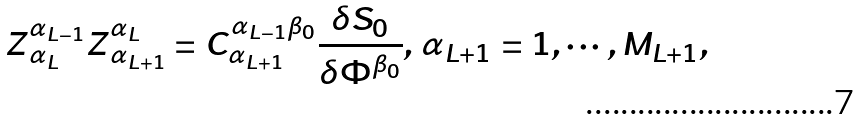Convert formula to latex. <formula><loc_0><loc_0><loc_500><loc_500>Z _ { \, \alpha _ { L } } ^ { \alpha _ { L - 1 } } Z _ { \, \alpha _ { L + 1 } } ^ { \alpha _ { L } } = C _ { \alpha _ { L + 1 } } ^ { \alpha _ { L - 1 } \beta _ { 0 } } \frac { \delta S _ { 0 } } { \delta \Phi ^ { \beta _ { 0 } } } , \, \alpha _ { L + 1 } = 1 , \cdots , M _ { L + 1 } ,</formula> 